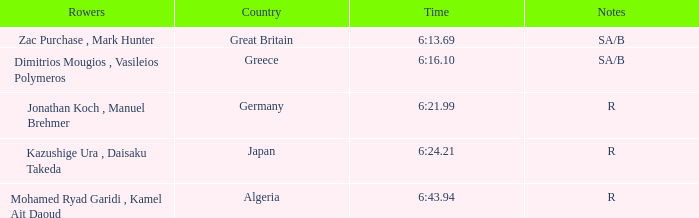What are the notes with the time 6:24.21? R. 